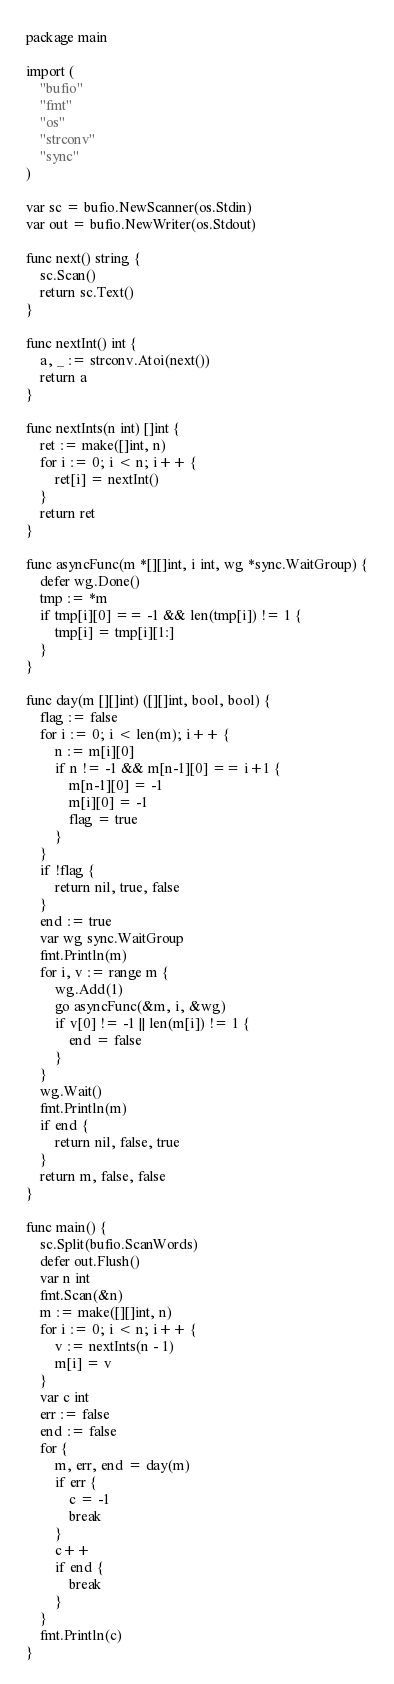<code> <loc_0><loc_0><loc_500><loc_500><_Go_>package main

import (
	"bufio"
	"fmt"
	"os"
	"strconv"
	"sync"
)

var sc = bufio.NewScanner(os.Stdin)
var out = bufio.NewWriter(os.Stdout)

func next() string {
	sc.Scan()
	return sc.Text()
}

func nextInt() int {
	a, _ := strconv.Atoi(next())
	return a
}

func nextInts(n int) []int {
	ret := make([]int, n)
	for i := 0; i < n; i++ {
		ret[i] = nextInt()
	}
	return ret
}

func asyncFunc(m *[][]int, i int, wg *sync.WaitGroup) {
	defer wg.Done()
	tmp := *m
	if tmp[i][0] == -1 && len(tmp[i]) != 1 {
		tmp[i] = tmp[i][1:]
	}
}

func day(m [][]int) ([][]int, bool, bool) {
	flag := false
	for i := 0; i < len(m); i++ {
		n := m[i][0]
		if n != -1 && m[n-1][0] == i+1 {
			m[n-1][0] = -1
			m[i][0] = -1
			flag = true
		}
	}
	if !flag {
		return nil, true, false
	}
	end := true
	var wg sync.WaitGroup
	fmt.Println(m)
	for i, v := range m {
		wg.Add(1)
		go asyncFunc(&m, i, &wg)
		if v[0] != -1 || len(m[i]) != 1 {
			end = false
		}
	}
	wg.Wait()
	fmt.Println(m)
	if end {
		return nil, false, true
	}
	return m, false, false
}

func main() {
	sc.Split(bufio.ScanWords)
	defer out.Flush()
	var n int
	fmt.Scan(&n)
	m := make([][]int, n)
	for i := 0; i < n; i++ {
		v := nextInts(n - 1)
		m[i] = v
	}
	var c int
	err := false
	end := false
	for {
		m, err, end = day(m)
		if err {
			c = -1
			break
		}
		c++
		if end {
			break
		}
	}
	fmt.Println(c)
}
</code> 